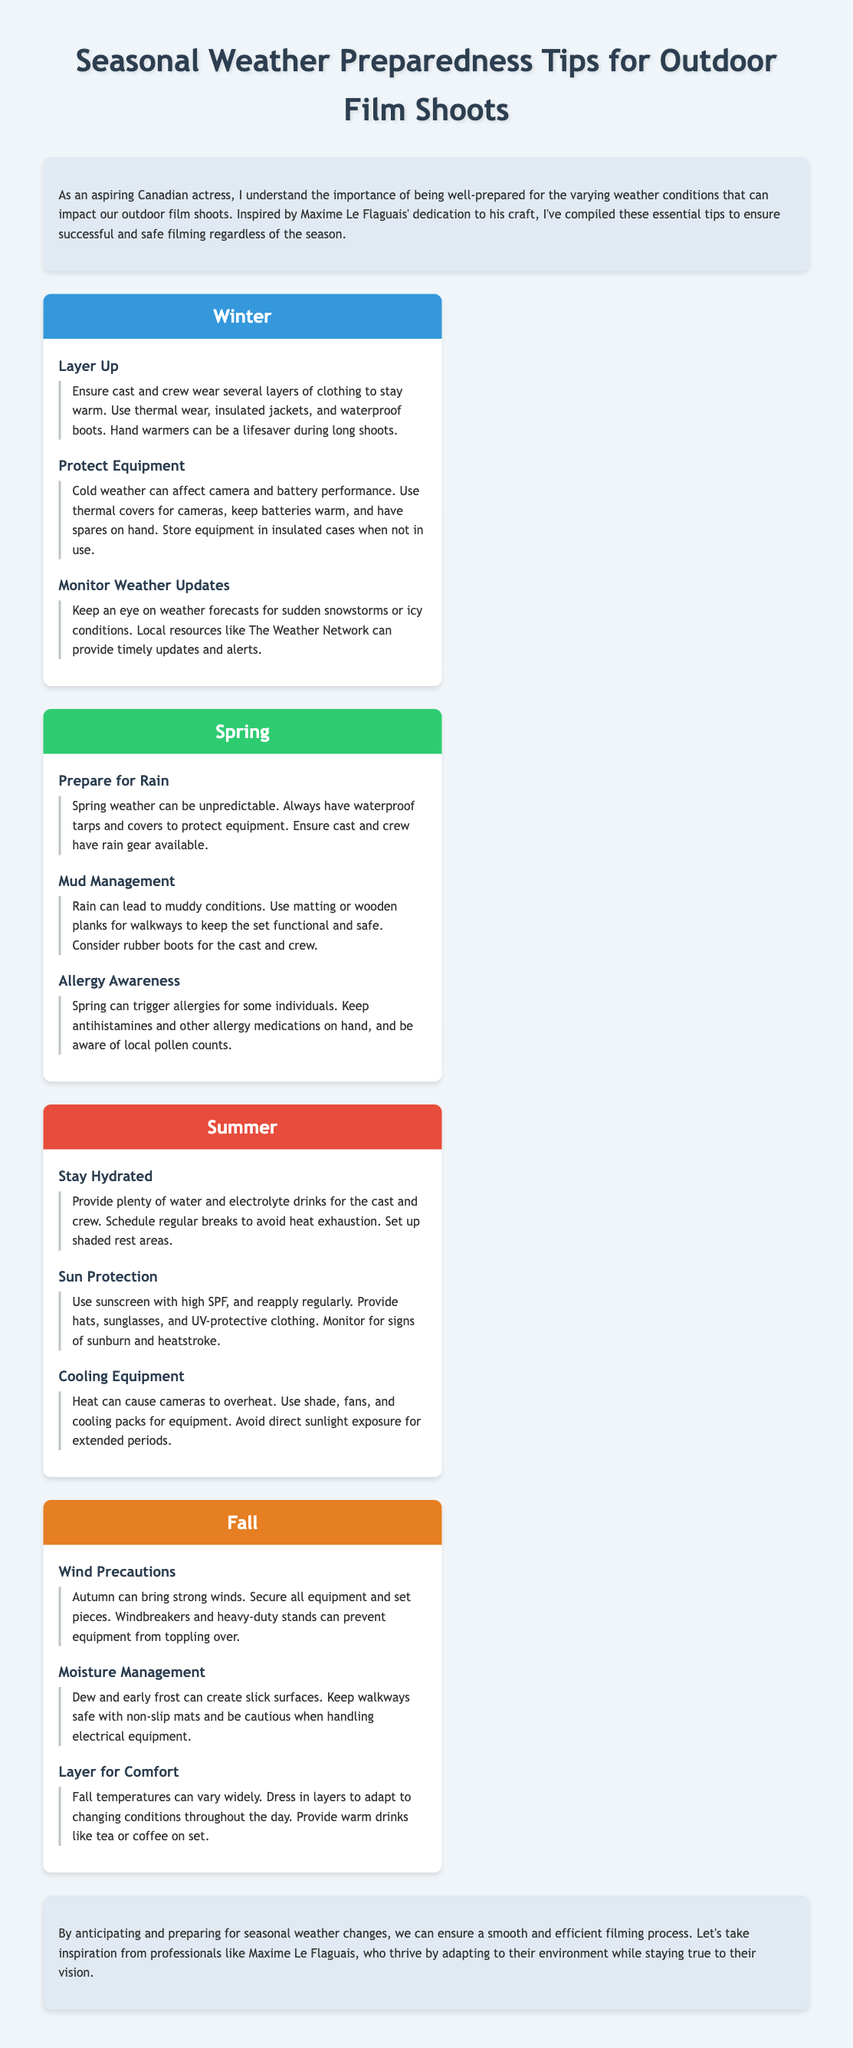What is the title of the document? The title is specified in the document's header section, which provides a clear indication of its content.
Answer: Seasonal Weather Preparedness Tips for Outdoor Film Shoots What season is marked by the color #3498db? The color codes used in the document indicate the specific seasons, and #3498db corresponds to winter.
Answer: Winter How many tips are provided for summer? The document contains sections for each season with specific tips, and the summer section lists three individual tips.
Answer: 3 What should cast and crew wear in winter for warmth? The winter section specifies that layering is essential, and it includes specific items to ensure warmth.
Answer: Several layers of clothing Which season emphasizes allergy awareness? The spring section highlights various preparations, including the need for awareness regarding allergies.
Answer: Spring What do you need to manage mud in spring? The spring tips suggest actions to mitigate muddy conditions for better set navigation and safety.
Answer: Matting or wooden planks What is a precaution mentioned for windy conditions in fall? The fall section describes measures to secure equipment against the potential dangers posed by wind.
Answer: Secure all equipment What is recommended to protect equipment in winter? The document provides specific tips about maintaining equipment during cold weather to ensure functionality.
Answer: Thermal covers for cameras How often should sunscreen be reapplied in summer? Although the document does not specify a number, it emphasizes the importance of regular reapplication throughout the day.
Answer: Regularly 